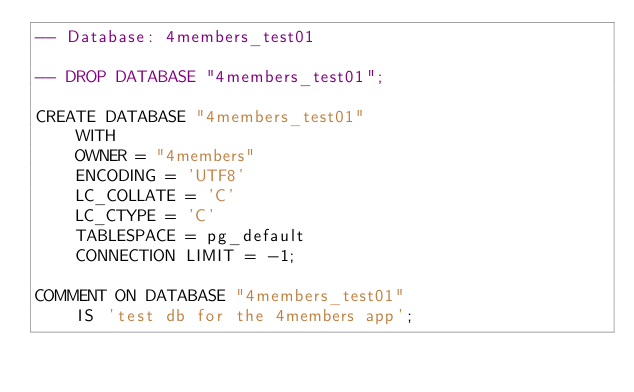<code> <loc_0><loc_0><loc_500><loc_500><_SQL_>-- Database: 4members_test01

-- DROP DATABASE "4members_test01";

CREATE DATABASE "4members_test01"
    WITH 
    OWNER = "4members"
    ENCODING = 'UTF8'
    LC_COLLATE = 'C'
    LC_CTYPE = 'C'
    TABLESPACE = pg_default
    CONNECTION LIMIT = -1;

COMMENT ON DATABASE "4members_test01"
    IS 'test db for the 4members app';</code> 